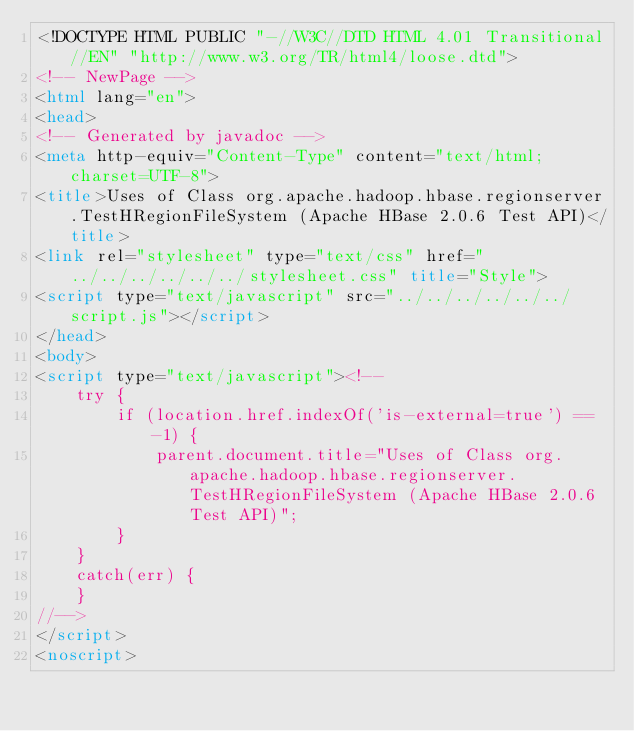<code> <loc_0><loc_0><loc_500><loc_500><_HTML_><!DOCTYPE HTML PUBLIC "-//W3C//DTD HTML 4.01 Transitional//EN" "http://www.w3.org/TR/html4/loose.dtd">
<!-- NewPage -->
<html lang="en">
<head>
<!-- Generated by javadoc -->
<meta http-equiv="Content-Type" content="text/html; charset=UTF-8">
<title>Uses of Class org.apache.hadoop.hbase.regionserver.TestHRegionFileSystem (Apache HBase 2.0.6 Test API)</title>
<link rel="stylesheet" type="text/css" href="../../../../../../stylesheet.css" title="Style">
<script type="text/javascript" src="../../../../../../script.js"></script>
</head>
<body>
<script type="text/javascript"><!--
    try {
        if (location.href.indexOf('is-external=true') == -1) {
            parent.document.title="Uses of Class org.apache.hadoop.hbase.regionserver.TestHRegionFileSystem (Apache HBase 2.0.6 Test API)";
        }
    }
    catch(err) {
    }
//-->
</script>
<noscript></code> 